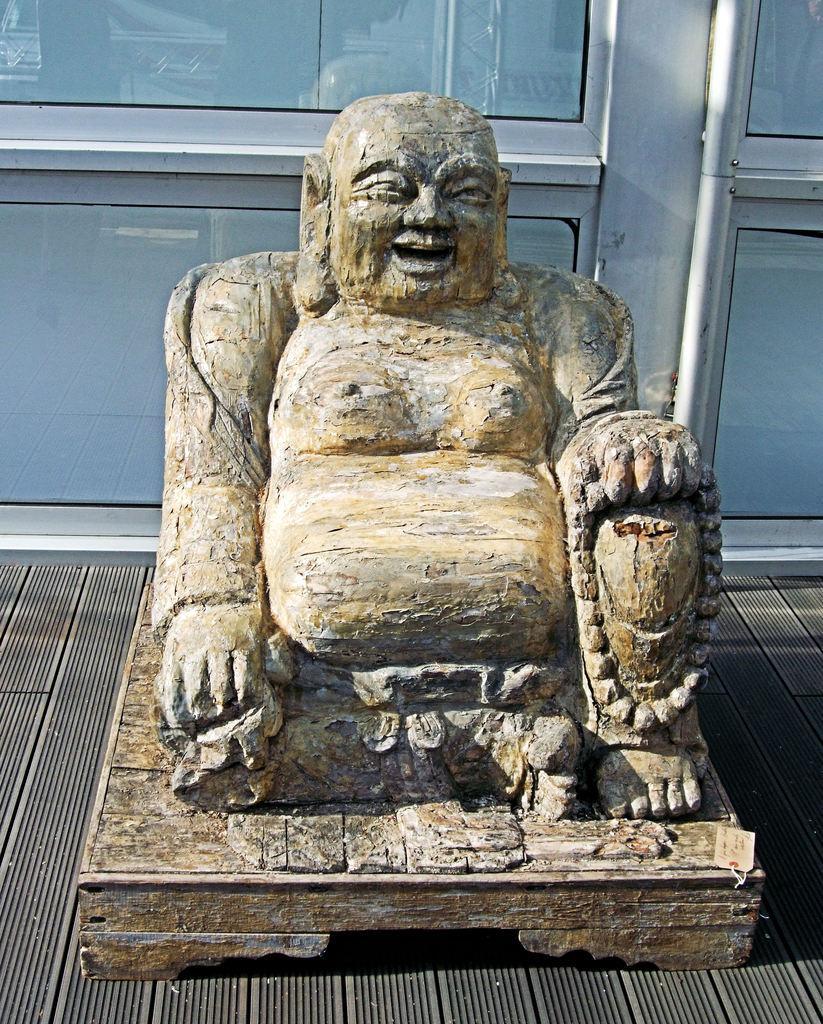Describe this image in one or two sentences. In this image I can see the statue of the laughing buddha. In the background I can see few glass doors. 